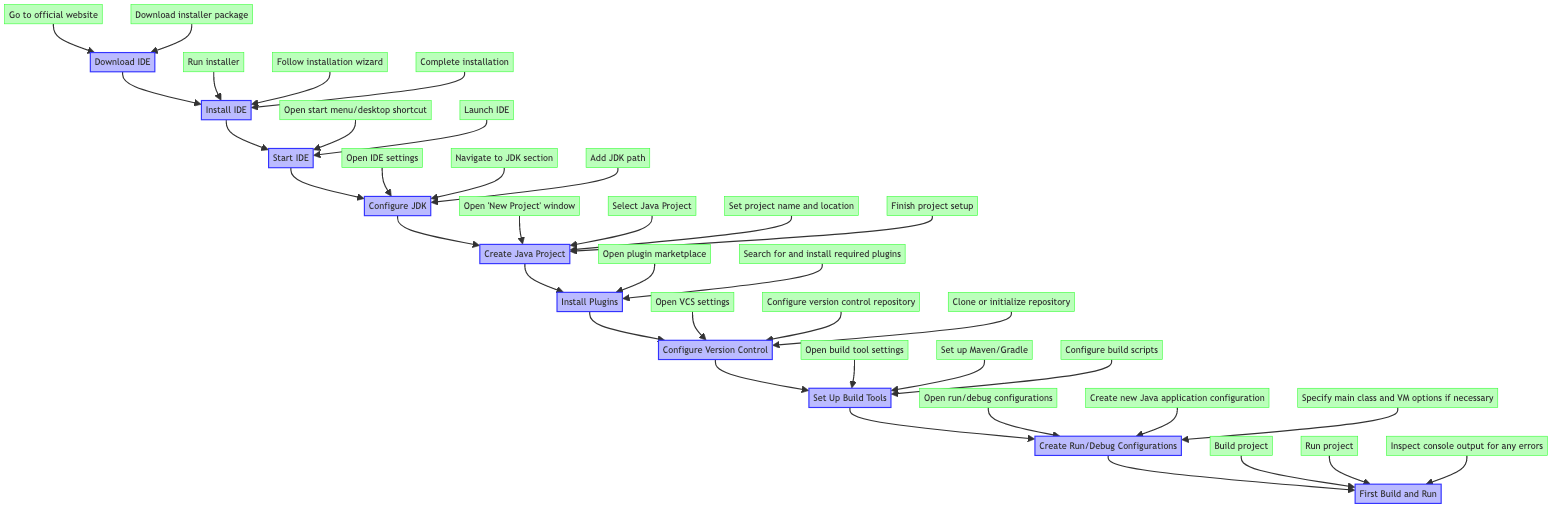What is the first step in the diagram? The diagram starts with the node labeled "Download IDE," which indicates that this is the first action to take before proceeding to subsequent steps.
Answer: Download IDE How many main steps are there in the flow chart? Counting the main steps from "Download IDE" to "First Build and Run," there are a total of ten steps represented in the flow chart.
Answer: Ten Which action follows after "Create Java Project"? After "Create Java Project," the next action mentioned in the flow chart is "Install Plugins," indicating the progression from project creation to enhancing the IDE.
Answer: Install Plugins What is the purpose of configuring the JDK? The purpose of configuring the JDK, as described in the chart, is to set up the Java Development Kit in the IDE settings to ensure a proper Java development environment.
Answer: Proper Java development environment Which action directly precedes "First Build and Run"? The action that directly precedes "First Build and Run" is "Create Run/Debug Configurations." This indicates that to successfully build and run, configurations must first be established.
Answer: Create Run/Debug Configurations How does "Install IDE" relate to "Download IDE"? "Install IDE" is the immediate successor to "Download IDE." After downloading the IDE, the very next action involves installing it using the downloaded installer.
Answer: Immediate successor What are the two actions needed to start the IDE? The two actions needed to start the IDE are to "Open start menu/desktop shortcut" and "Launch IDE," which are necessary steps following the installation.
Answer: Open start menu/desktop shortcut and Launch IDE What is the final step in the diagram? The final step in the flow chart is "First Build and Run," which signifies the culmination of all prior configurations and setups leading to executing the project.
Answer: First Build and Run How many actions are needed to install plugins? To install plugins, there are two actions required according to the flow chart: "Open plugin marketplace" and "Search for and install required plugins."
Answer: Two actions 